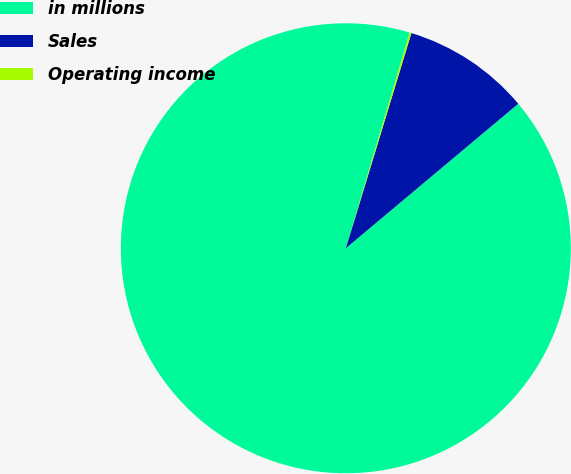Convert chart to OTSL. <chart><loc_0><loc_0><loc_500><loc_500><pie_chart><fcel>in millions<fcel>Sales<fcel>Operating income<nl><fcel>90.68%<fcel>9.19%<fcel>0.13%<nl></chart> 